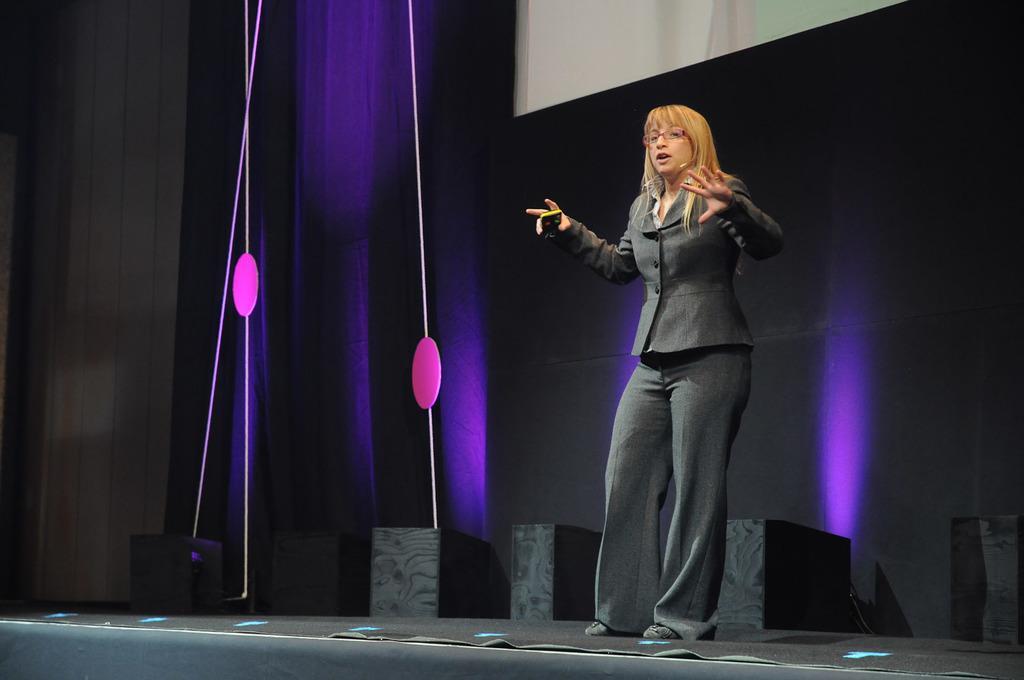Can you describe this image briefly? A woman is standing wearing suit on the stage. 